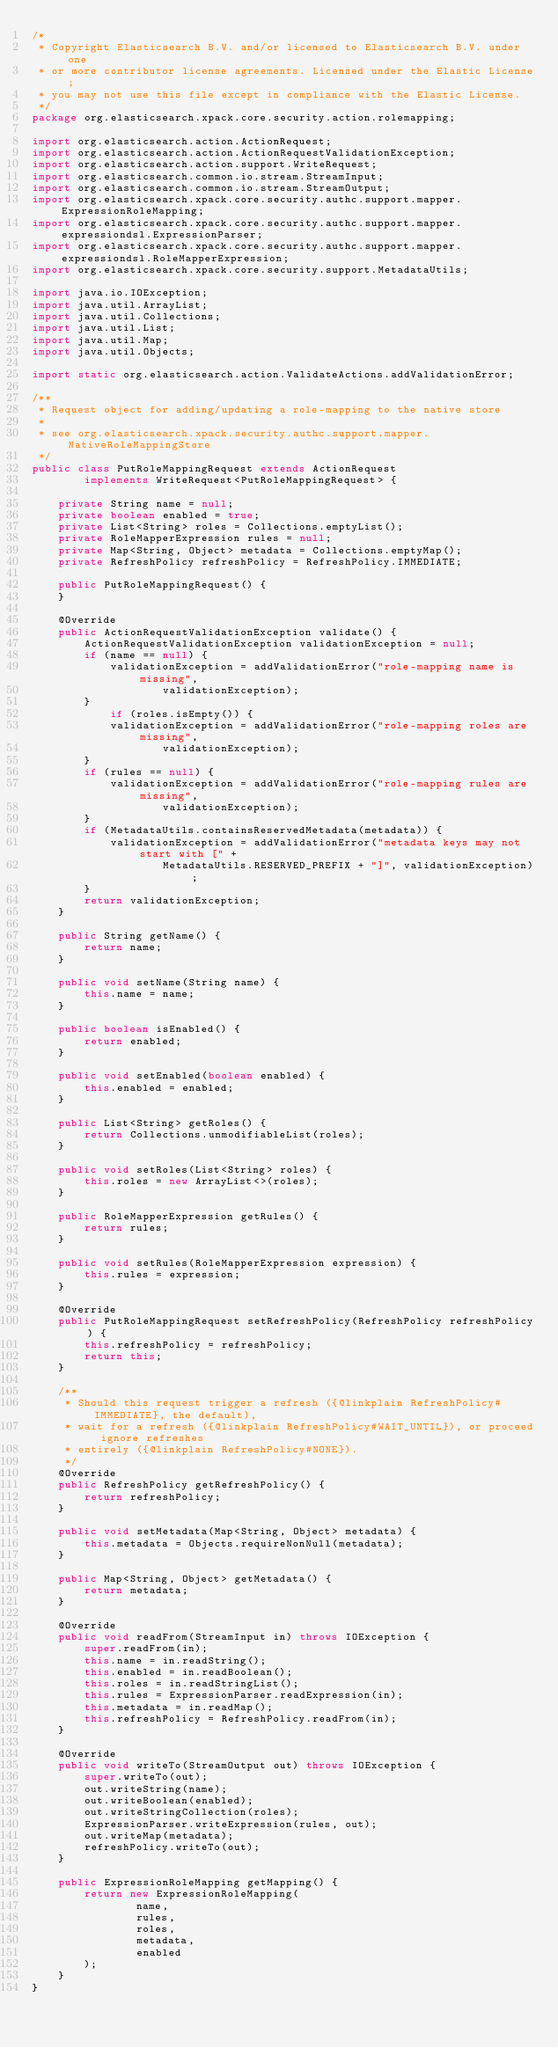<code> <loc_0><loc_0><loc_500><loc_500><_Java_>/*
 * Copyright Elasticsearch B.V. and/or licensed to Elasticsearch B.V. under one
 * or more contributor license agreements. Licensed under the Elastic License;
 * you may not use this file except in compliance with the Elastic License.
 */
package org.elasticsearch.xpack.core.security.action.rolemapping;

import org.elasticsearch.action.ActionRequest;
import org.elasticsearch.action.ActionRequestValidationException;
import org.elasticsearch.action.support.WriteRequest;
import org.elasticsearch.common.io.stream.StreamInput;
import org.elasticsearch.common.io.stream.StreamOutput;
import org.elasticsearch.xpack.core.security.authc.support.mapper.ExpressionRoleMapping;
import org.elasticsearch.xpack.core.security.authc.support.mapper.expressiondsl.ExpressionParser;
import org.elasticsearch.xpack.core.security.authc.support.mapper.expressiondsl.RoleMapperExpression;
import org.elasticsearch.xpack.core.security.support.MetadataUtils;

import java.io.IOException;
import java.util.ArrayList;
import java.util.Collections;
import java.util.List;
import java.util.Map;
import java.util.Objects;

import static org.elasticsearch.action.ValidateActions.addValidationError;

/**
 * Request object for adding/updating a role-mapping to the native store
 *
 * see org.elasticsearch.xpack.security.authc.support.mapper.NativeRoleMappingStore
 */
public class PutRoleMappingRequest extends ActionRequest
        implements WriteRequest<PutRoleMappingRequest> {

    private String name = null;
    private boolean enabled = true;
    private List<String> roles = Collections.emptyList();
    private RoleMapperExpression rules = null;
    private Map<String, Object> metadata = Collections.emptyMap();
    private RefreshPolicy refreshPolicy = RefreshPolicy.IMMEDIATE;

    public PutRoleMappingRequest() {
    }

    @Override
    public ActionRequestValidationException validate() {
        ActionRequestValidationException validationException = null;
        if (name == null) {
            validationException = addValidationError("role-mapping name is missing",
                    validationException);
        }
            if (roles.isEmpty()) {
            validationException = addValidationError("role-mapping roles are missing",
                    validationException);
        }
        if (rules == null) {
            validationException = addValidationError("role-mapping rules are missing",
                    validationException);
        }
        if (MetadataUtils.containsReservedMetadata(metadata)) {
            validationException = addValidationError("metadata keys may not start with [" +
                    MetadataUtils.RESERVED_PREFIX + "]", validationException);
        }
        return validationException;
    }

    public String getName() {
        return name;
    }

    public void setName(String name) {
        this.name = name;
    }

    public boolean isEnabled() {
        return enabled;
    }

    public void setEnabled(boolean enabled) {
        this.enabled = enabled;
    }

    public List<String> getRoles() {
        return Collections.unmodifiableList(roles);
    }

    public void setRoles(List<String> roles) {
        this.roles = new ArrayList<>(roles);
    }

    public RoleMapperExpression getRules() {
        return rules;
    }

    public void setRules(RoleMapperExpression expression) {
        this.rules = expression;
    }

    @Override
    public PutRoleMappingRequest setRefreshPolicy(RefreshPolicy refreshPolicy) {
        this.refreshPolicy = refreshPolicy;
        return this;
    }

    /**
     * Should this request trigger a refresh ({@linkplain RefreshPolicy#IMMEDIATE}, the default),
     * wait for a refresh ({@linkplain RefreshPolicy#WAIT_UNTIL}), or proceed ignore refreshes
     * entirely ({@linkplain RefreshPolicy#NONE}).
     */
    @Override
    public RefreshPolicy getRefreshPolicy() {
        return refreshPolicy;
    }

    public void setMetadata(Map<String, Object> metadata) {
        this.metadata = Objects.requireNonNull(metadata);
    }

    public Map<String, Object> getMetadata() {
        return metadata;
    }

    @Override
    public void readFrom(StreamInput in) throws IOException {
        super.readFrom(in);
        this.name = in.readString();
        this.enabled = in.readBoolean();
        this.roles = in.readStringList();
        this.rules = ExpressionParser.readExpression(in);
        this.metadata = in.readMap();
        this.refreshPolicy = RefreshPolicy.readFrom(in);
    }

    @Override
    public void writeTo(StreamOutput out) throws IOException {
        super.writeTo(out);
        out.writeString(name);
        out.writeBoolean(enabled);
        out.writeStringCollection(roles);
        ExpressionParser.writeExpression(rules, out);
        out.writeMap(metadata);
        refreshPolicy.writeTo(out);
    }

    public ExpressionRoleMapping getMapping() {
        return new ExpressionRoleMapping(
                name,
                rules,
                roles,
                metadata,
                enabled
        );
    }
}
</code> 